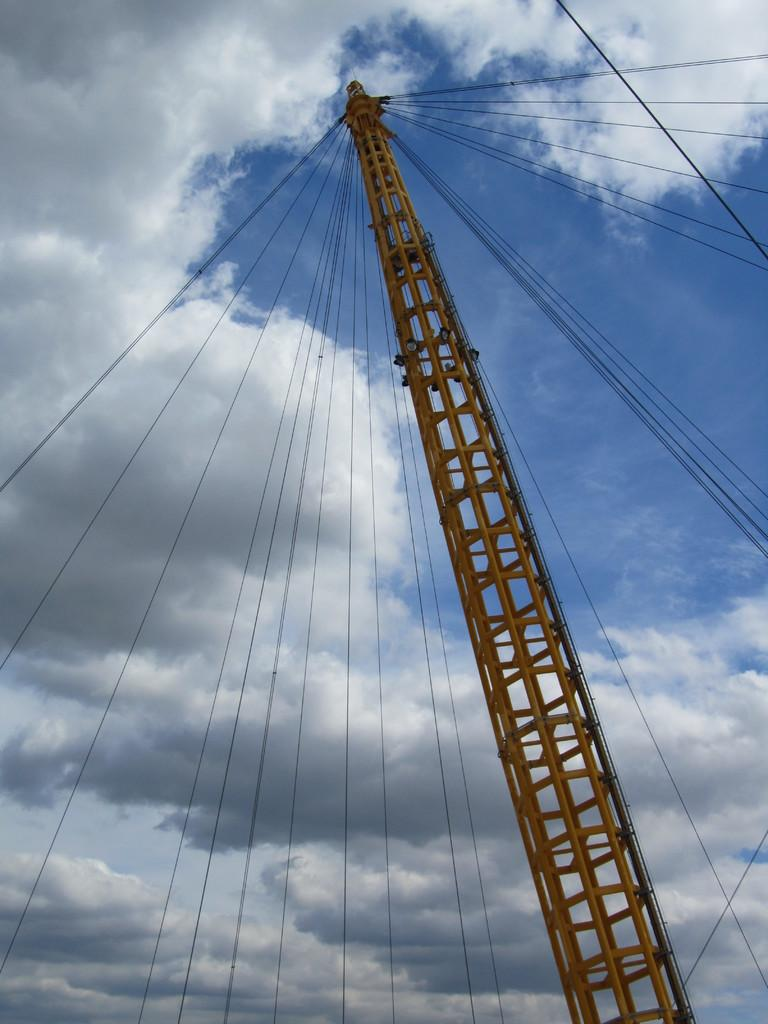What is the main subject of the image? The main subject of the image is a giant construction crane. What is attached to the crane? Plenty of wires are attached to the crane. Where are the wires attached on the crane? The wires are attached from the tip of the crane. What can be seen above the crane in the image? The sky is visible above the crane. How many ducks are swimming in the water near the crane in the image? There are no ducks or water present in the image; it features a giant construction crane with wires attached to it. What type of dinosaurs can be seen interacting with the crane in the image? There are no dinosaurs present in the image; it features a giant construction crane with wires attached to it. 